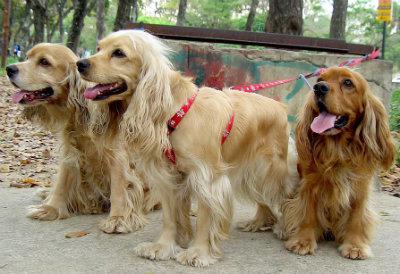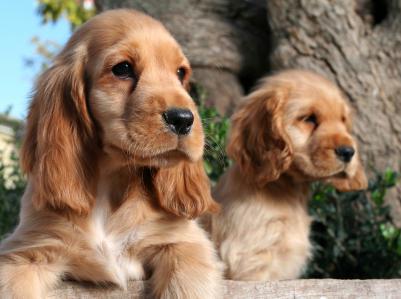The first image is the image on the left, the second image is the image on the right. Analyze the images presented: Is the assertion "There are at most four dogs." valid? Answer yes or no. No. The first image is the image on the left, the second image is the image on the right. Considering the images on both sides, is "At least one half of the dogs have their mouths open." valid? Answer yes or no. Yes. 